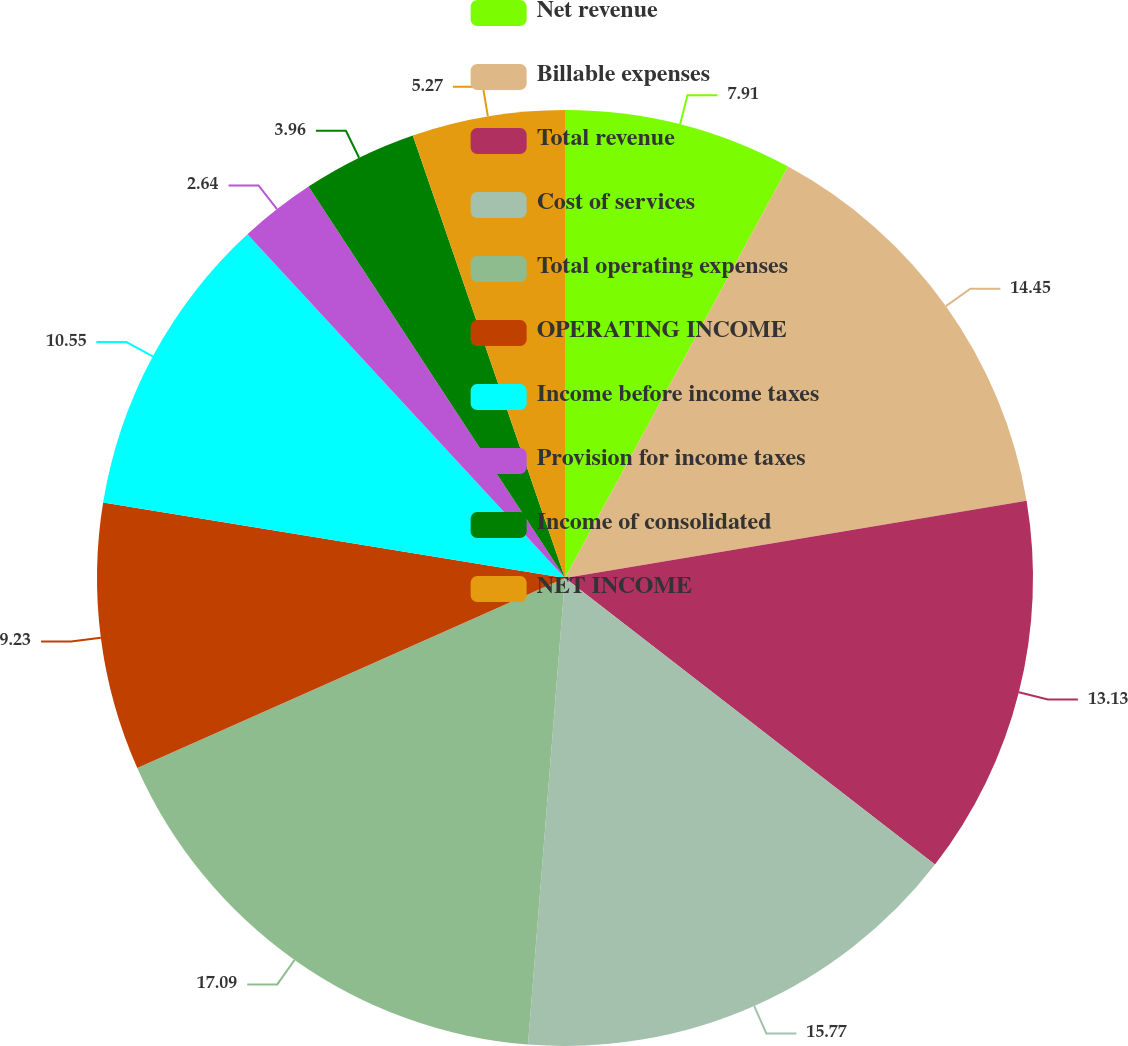<chart> <loc_0><loc_0><loc_500><loc_500><pie_chart><fcel>Net revenue<fcel>Billable expenses<fcel>Total revenue<fcel>Cost of services<fcel>Total operating expenses<fcel>OPERATING INCOME<fcel>Income before income taxes<fcel>Provision for income taxes<fcel>Income of consolidated<fcel>NET INCOME<nl><fcel>7.91%<fcel>14.45%<fcel>13.13%<fcel>15.77%<fcel>17.09%<fcel>9.23%<fcel>10.55%<fcel>2.64%<fcel>3.96%<fcel>5.27%<nl></chart> 